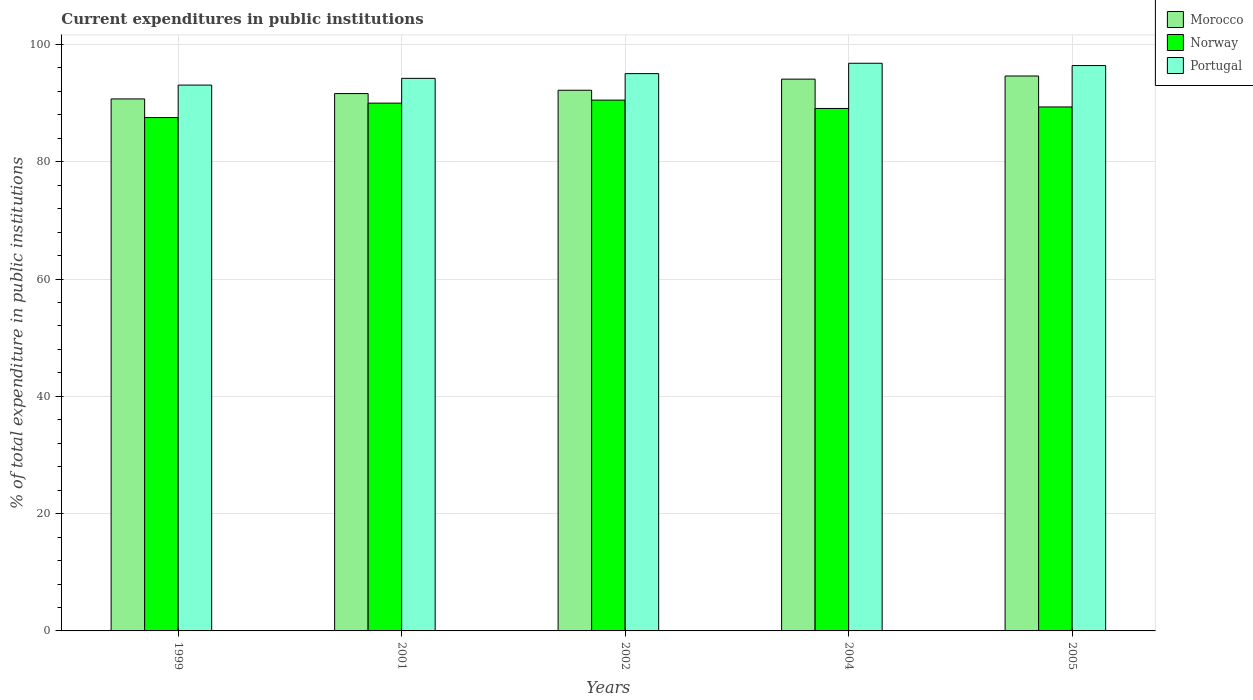How many groups of bars are there?
Offer a very short reply. 5. Are the number of bars per tick equal to the number of legend labels?
Make the answer very short. Yes. How many bars are there on the 4th tick from the left?
Your response must be concise. 3. How many bars are there on the 1st tick from the right?
Keep it short and to the point. 3. What is the current expenditures in public institutions in Norway in 1999?
Ensure brevity in your answer.  87.53. Across all years, what is the maximum current expenditures in public institutions in Norway?
Keep it short and to the point. 90.51. Across all years, what is the minimum current expenditures in public institutions in Morocco?
Offer a terse response. 90.71. What is the total current expenditures in public institutions in Norway in the graph?
Your response must be concise. 446.46. What is the difference between the current expenditures in public institutions in Portugal in 2002 and that in 2004?
Provide a short and direct response. -1.77. What is the difference between the current expenditures in public institutions in Portugal in 1999 and the current expenditures in public institutions in Morocco in 2004?
Give a very brief answer. -1.01. What is the average current expenditures in public institutions in Morocco per year?
Provide a short and direct response. 92.65. In the year 2002, what is the difference between the current expenditures in public institutions in Morocco and current expenditures in public institutions in Portugal?
Make the answer very short. -2.84. In how many years, is the current expenditures in public institutions in Portugal greater than 64 %?
Give a very brief answer. 5. What is the ratio of the current expenditures in public institutions in Norway in 2002 to that in 2004?
Offer a very short reply. 1.02. What is the difference between the highest and the second highest current expenditures in public institutions in Norway?
Your response must be concise. 0.52. What is the difference between the highest and the lowest current expenditures in public institutions in Norway?
Your answer should be compact. 2.98. Is the sum of the current expenditures in public institutions in Norway in 1999 and 2005 greater than the maximum current expenditures in public institutions in Morocco across all years?
Offer a terse response. Yes. What does the 2nd bar from the left in 2001 represents?
Your answer should be very brief. Norway. How many bars are there?
Offer a terse response. 15. Are all the bars in the graph horizontal?
Make the answer very short. No. How many years are there in the graph?
Your response must be concise. 5. Are the values on the major ticks of Y-axis written in scientific E-notation?
Your answer should be very brief. No. Where does the legend appear in the graph?
Ensure brevity in your answer.  Top right. How many legend labels are there?
Your response must be concise. 3. What is the title of the graph?
Your answer should be compact. Current expenditures in public institutions. What is the label or title of the X-axis?
Provide a short and direct response. Years. What is the label or title of the Y-axis?
Offer a terse response. % of total expenditure in public institutions. What is the % of total expenditure in public institutions of Morocco in 1999?
Offer a terse response. 90.71. What is the % of total expenditure in public institutions in Norway in 1999?
Give a very brief answer. 87.53. What is the % of total expenditure in public institutions of Portugal in 1999?
Provide a short and direct response. 93.07. What is the % of total expenditure in public institutions in Morocco in 2001?
Offer a terse response. 91.63. What is the % of total expenditure in public institutions in Norway in 2001?
Your answer should be compact. 89.99. What is the % of total expenditure in public institutions in Portugal in 2001?
Make the answer very short. 94.22. What is the % of total expenditure in public institutions of Morocco in 2002?
Keep it short and to the point. 92.19. What is the % of total expenditure in public institutions in Norway in 2002?
Your answer should be compact. 90.51. What is the % of total expenditure in public institutions of Portugal in 2002?
Your answer should be very brief. 95.03. What is the % of total expenditure in public institutions in Morocco in 2004?
Provide a short and direct response. 94.09. What is the % of total expenditure in public institutions in Norway in 2004?
Offer a very short reply. 89.09. What is the % of total expenditure in public institutions in Portugal in 2004?
Make the answer very short. 96.79. What is the % of total expenditure in public institutions in Morocco in 2005?
Provide a succinct answer. 94.62. What is the % of total expenditure in public institutions in Norway in 2005?
Provide a succinct answer. 89.34. What is the % of total expenditure in public institutions of Portugal in 2005?
Ensure brevity in your answer.  96.4. Across all years, what is the maximum % of total expenditure in public institutions in Morocco?
Your answer should be very brief. 94.62. Across all years, what is the maximum % of total expenditure in public institutions of Norway?
Make the answer very short. 90.51. Across all years, what is the maximum % of total expenditure in public institutions in Portugal?
Make the answer very short. 96.79. Across all years, what is the minimum % of total expenditure in public institutions of Morocco?
Your answer should be very brief. 90.71. Across all years, what is the minimum % of total expenditure in public institutions of Norway?
Offer a very short reply. 87.53. Across all years, what is the minimum % of total expenditure in public institutions of Portugal?
Make the answer very short. 93.07. What is the total % of total expenditure in public institutions of Morocco in the graph?
Keep it short and to the point. 463.23. What is the total % of total expenditure in public institutions in Norway in the graph?
Your answer should be very brief. 446.46. What is the total % of total expenditure in public institutions in Portugal in the graph?
Offer a very short reply. 475.51. What is the difference between the % of total expenditure in public institutions in Morocco in 1999 and that in 2001?
Your response must be concise. -0.92. What is the difference between the % of total expenditure in public institutions of Norway in 1999 and that in 2001?
Make the answer very short. -2.46. What is the difference between the % of total expenditure in public institutions in Portugal in 1999 and that in 2001?
Provide a short and direct response. -1.15. What is the difference between the % of total expenditure in public institutions of Morocco in 1999 and that in 2002?
Keep it short and to the point. -1.48. What is the difference between the % of total expenditure in public institutions in Norway in 1999 and that in 2002?
Provide a succinct answer. -2.98. What is the difference between the % of total expenditure in public institutions in Portugal in 1999 and that in 2002?
Offer a terse response. -1.96. What is the difference between the % of total expenditure in public institutions in Morocco in 1999 and that in 2004?
Ensure brevity in your answer.  -3.38. What is the difference between the % of total expenditure in public institutions in Norway in 1999 and that in 2004?
Offer a very short reply. -1.55. What is the difference between the % of total expenditure in public institutions in Portugal in 1999 and that in 2004?
Give a very brief answer. -3.72. What is the difference between the % of total expenditure in public institutions in Morocco in 1999 and that in 2005?
Provide a short and direct response. -3.91. What is the difference between the % of total expenditure in public institutions in Norway in 1999 and that in 2005?
Your response must be concise. -1.81. What is the difference between the % of total expenditure in public institutions of Portugal in 1999 and that in 2005?
Provide a short and direct response. -3.33. What is the difference between the % of total expenditure in public institutions of Morocco in 2001 and that in 2002?
Provide a short and direct response. -0.57. What is the difference between the % of total expenditure in public institutions of Norway in 2001 and that in 2002?
Your response must be concise. -0.52. What is the difference between the % of total expenditure in public institutions in Portugal in 2001 and that in 2002?
Ensure brevity in your answer.  -0.8. What is the difference between the % of total expenditure in public institutions of Morocco in 2001 and that in 2004?
Your answer should be very brief. -2.46. What is the difference between the % of total expenditure in public institutions in Norway in 2001 and that in 2004?
Your answer should be compact. 0.91. What is the difference between the % of total expenditure in public institutions in Portugal in 2001 and that in 2004?
Keep it short and to the point. -2.57. What is the difference between the % of total expenditure in public institutions of Morocco in 2001 and that in 2005?
Ensure brevity in your answer.  -2.99. What is the difference between the % of total expenditure in public institutions in Norway in 2001 and that in 2005?
Make the answer very short. 0.65. What is the difference between the % of total expenditure in public institutions of Portugal in 2001 and that in 2005?
Give a very brief answer. -2.18. What is the difference between the % of total expenditure in public institutions of Morocco in 2002 and that in 2004?
Offer a very short reply. -1.89. What is the difference between the % of total expenditure in public institutions of Norway in 2002 and that in 2004?
Your answer should be compact. 1.42. What is the difference between the % of total expenditure in public institutions of Portugal in 2002 and that in 2004?
Your answer should be very brief. -1.77. What is the difference between the % of total expenditure in public institutions of Morocco in 2002 and that in 2005?
Make the answer very short. -2.43. What is the difference between the % of total expenditure in public institutions of Norway in 2002 and that in 2005?
Your answer should be very brief. 1.17. What is the difference between the % of total expenditure in public institutions of Portugal in 2002 and that in 2005?
Offer a very short reply. -1.37. What is the difference between the % of total expenditure in public institutions in Morocco in 2004 and that in 2005?
Make the answer very short. -0.53. What is the difference between the % of total expenditure in public institutions of Norway in 2004 and that in 2005?
Your answer should be compact. -0.26. What is the difference between the % of total expenditure in public institutions of Portugal in 2004 and that in 2005?
Provide a succinct answer. 0.39. What is the difference between the % of total expenditure in public institutions in Morocco in 1999 and the % of total expenditure in public institutions in Norway in 2001?
Ensure brevity in your answer.  0.72. What is the difference between the % of total expenditure in public institutions of Morocco in 1999 and the % of total expenditure in public institutions of Portugal in 2001?
Give a very brief answer. -3.51. What is the difference between the % of total expenditure in public institutions in Norway in 1999 and the % of total expenditure in public institutions in Portugal in 2001?
Your answer should be compact. -6.69. What is the difference between the % of total expenditure in public institutions in Morocco in 1999 and the % of total expenditure in public institutions in Norway in 2002?
Provide a succinct answer. 0.2. What is the difference between the % of total expenditure in public institutions in Morocco in 1999 and the % of total expenditure in public institutions in Portugal in 2002?
Give a very brief answer. -4.32. What is the difference between the % of total expenditure in public institutions of Norway in 1999 and the % of total expenditure in public institutions of Portugal in 2002?
Offer a very short reply. -7.49. What is the difference between the % of total expenditure in public institutions in Morocco in 1999 and the % of total expenditure in public institutions in Norway in 2004?
Offer a terse response. 1.62. What is the difference between the % of total expenditure in public institutions in Morocco in 1999 and the % of total expenditure in public institutions in Portugal in 2004?
Your response must be concise. -6.08. What is the difference between the % of total expenditure in public institutions in Norway in 1999 and the % of total expenditure in public institutions in Portugal in 2004?
Offer a very short reply. -9.26. What is the difference between the % of total expenditure in public institutions in Morocco in 1999 and the % of total expenditure in public institutions in Norway in 2005?
Provide a succinct answer. 1.37. What is the difference between the % of total expenditure in public institutions in Morocco in 1999 and the % of total expenditure in public institutions in Portugal in 2005?
Provide a short and direct response. -5.69. What is the difference between the % of total expenditure in public institutions in Norway in 1999 and the % of total expenditure in public institutions in Portugal in 2005?
Ensure brevity in your answer.  -8.87. What is the difference between the % of total expenditure in public institutions of Morocco in 2001 and the % of total expenditure in public institutions of Norway in 2002?
Your answer should be very brief. 1.12. What is the difference between the % of total expenditure in public institutions in Morocco in 2001 and the % of total expenditure in public institutions in Portugal in 2002?
Offer a very short reply. -3.4. What is the difference between the % of total expenditure in public institutions in Norway in 2001 and the % of total expenditure in public institutions in Portugal in 2002?
Ensure brevity in your answer.  -5.03. What is the difference between the % of total expenditure in public institutions of Morocco in 2001 and the % of total expenditure in public institutions of Norway in 2004?
Offer a terse response. 2.54. What is the difference between the % of total expenditure in public institutions of Morocco in 2001 and the % of total expenditure in public institutions of Portugal in 2004?
Your answer should be very brief. -5.17. What is the difference between the % of total expenditure in public institutions in Norway in 2001 and the % of total expenditure in public institutions in Portugal in 2004?
Your response must be concise. -6.8. What is the difference between the % of total expenditure in public institutions of Morocco in 2001 and the % of total expenditure in public institutions of Norway in 2005?
Your response must be concise. 2.28. What is the difference between the % of total expenditure in public institutions in Morocco in 2001 and the % of total expenditure in public institutions in Portugal in 2005?
Make the answer very short. -4.77. What is the difference between the % of total expenditure in public institutions in Norway in 2001 and the % of total expenditure in public institutions in Portugal in 2005?
Your response must be concise. -6.41. What is the difference between the % of total expenditure in public institutions in Morocco in 2002 and the % of total expenditure in public institutions in Norway in 2004?
Provide a succinct answer. 3.11. What is the difference between the % of total expenditure in public institutions of Morocco in 2002 and the % of total expenditure in public institutions of Portugal in 2004?
Ensure brevity in your answer.  -4.6. What is the difference between the % of total expenditure in public institutions of Norway in 2002 and the % of total expenditure in public institutions of Portugal in 2004?
Keep it short and to the point. -6.28. What is the difference between the % of total expenditure in public institutions in Morocco in 2002 and the % of total expenditure in public institutions in Norway in 2005?
Provide a short and direct response. 2.85. What is the difference between the % of total expenditure in public institutions of Morocco in 2002 and the % of total expenditure in public institutions of Portugal in 2005?
Provide a succinct answer. -4.21. What is the difference between the % of total expenditure in public institutions in Norway in 2002 and the % of total expenditure in public institutions in Portugal in 2005?
Offer a terse response. -5.89. What is the difference between the % of total expenditure in public institutions of Morocco in 2004 and the % of total expenditure in public institutions of Norway in 2005?
Give a very brief answer. 4.74. What is the difference between the % of total expenditure in public institutions in Morocco in 2004 and the % of total expenditure in public institutions in Portugal in 2005?
Make the answer very short. -2.32. What is the difference between the % of total expenditure in public institutions in Norway in 2004 and the % of total expenditure in public institutions in Portugal in 2005?
Offer a terse response. -7.31. What is the average % of total expenditure in public institutions of Morocco per year?
Ensure brevity in your answer.  92.65. What is the average % of total expenditure in public institutions of Norway per year?
Ensure brevity in your answer.  89.29. What is the average % of total expenditure in public institutions in Portugal per year?
Ensure brevity in your answer.  95.1. In the year 1999, what is the difference between the % of total expenditure in public institutions of Morocco and % of total expenditure in public institutions of Norway?
Your response must be concise. 3.18. In the year 1999, what is the difference between the % of total expenditure in public institutions of Morocco and % of total expenditure in public institutions of Portugal?
Your response must be concise. -2.36. In the year 1999, what is the difference between the % of total expenditure in public institutions in Norway and % of total expenditure in public institutions in Portugal?
Offer a terse response. -5.54. In the year 2001, what is the difference between the % of total expenditure in public institutions in Morocco and % of total expenditure in public institutions in Norway?
Give a very brief answer. 1.63. In the year 2001, what is the difference between the % of total expenditure in public institutions in Morocco and % of total expenditure in public institutions in Portugal?
Provide a short and direct response. -2.6. In the year 2001, what is the difference between the % of total expenditure in public institutions of Norway and % of total expenditure in public institutions of Portugal?
Your response must be concise. -4.23. In the year 2002, what is the difference between the % of total expenditure in public institutions of Morocco and % of total expenditure in public institutions of Norway?
Keep it short and to the point. 1.68. In the year 2002, what is the difference between the % of total expenditure in public institutions of Morocco and % of total expenditure in public institutions of Portugal?
Make the answer very short. -2.84. In the year 2002, what is the difference between the % of total expenditure in public institutions of Norway and % of total expenditure in public institutions of Portugal?
Your response must be concise. -4.52. In the year 2004, what is the difference between the % of total expenditure in public institutions in Morocco and % of total expenditure in public institutions in Norway?
Make the answer very short. 5. In the year 2004, what is the difference between the % of total expenditure in public institutions of Morocco and % of total expenditure in public institutions of Portugal?
Offer a terse response. -2.71. In the year 2004, what is the difference between the % of total expenditure in public institutions in Norway and % of total expenditure in public institutions in Portugal?
Provide a succinct answer. -7.71. In the year 2005, what is the difference between the % of total expenditure in public institutions of Morocco and % of total expenditure in public institutions of Norway?
Keep it short and to the point. 5.28. In the year 2005, what is the difference between the % of total expenditure in public institutions of Morocco and % of total expenditure in public institutions of Portugal?
Make the answer very short. -1.78. In the year 2005, what is the difference between the % of total expenditure in public institutions in Norway and % of total expenditure in public institutions in Portugal?
Your answer should be very brief. -7.06. What is the ratio of the % of total expenditure in public institutions of Norway in 1999 to that in 2001?
Your answer should be very brief. 0.97. What is the ratio of the % of total expenditure in public institutions in Portugal in 1999 to that in 2001?
Your answer should be compact. 0.99. What is the ratio of the % of total expenditure in public institutions of Morocco in 1999 to that in 2002?
Ensure brevity in your answer.  0.98. What is the ratio of the % of total expenditure in public institutions in Norway in 1999 to that in 2002?
Offer a very short reply. 0.97. What is the ratio of the % of total expenditure in public institutions in Portugal in 1999 to that in 2002?
Offer a terse response. 0.98. What is the ratio of the % of total expenditure in public institutions of Morocco in 1999 to that in 2004?
Keep it short and to the point. 0.96. What is the ratio of the % of total expenditure in public institutions in Norway in 1999 to that in 2004?
Your answer should be compact. 0.98. What is the ratio of the % of total expenditure in public institutions of Portugal in 1999 to that in 2004?
Your answer should be very brief. 0.96. What is the ratio of the % of total expenditure in public institutions of Morocco in 1999 to that in 2005?
Your answer should be very brief. 0.96. What is the ratio of the % of total expenditure in public institutions in Norway in 1999 to that in 2005?
Give a very brief answer. 0.98. What is the ratio of the % of total expenditure in public institutions in Portugal in 1999 to that in 2005?
Offer a very short reply. 0.97. What is the ratio of the % of total expenditure in public institutions of Morocco in 2001 to that in 2002?
Your answer should be compact. 0.99. What is the ratio of the % of total expenditure in public institutions of Norway in 2001 to that in 2002?
Ensure brevity in your answer.  0.99. What is the ratio of the % of total expenditure in public institutions of Morocco in 2001 to that in 2004?
Ensure brevity in your answer.  0.97. What is the ratio of the % of total expenditure in public institutions in Norway in 2001 to that in 2004?
Provide a short and direct response. 1.01. What is the ratio of the % of total expenditure in public institutions in Portugal in 2001 to that in 2004?
Offer a terse response. 0.97. What is the ratio of the % of total expenditure in public institutions of Morocco in 2001 to that in 2005?
Keep it short and to the point. 0.97. What is the ratio of the % of total expenditure in public institutions in Norway in 2001 to that in 2005?
Offer a terse response. 1.01. What is the ratio of the % of total expenditure in public institutions in Portugal in 2001 to that in 2005?
Your response must be concise. 0.98. What is the ratio of the % of total expenditure in public institutions in Morocco in 2002 to that in 2004?
Provide a succinct answer. 0.98. What is the ratio of the % of total expenditure in public institutions of Norway in 2002 to that in 2004?
Offer a very short reply. 1.02. What is the ratio of the % of total expenditure in public institutions of Portugal in 2002 to that in 2004?
Your response must be concise. 0.98. What is the ratio of the % of total expenditure in public institutions of Morocco in 2002 to that in 2005?
Offer a very short reply. 0.97. What is the ratio of the % of total expenditure in public institutions of Portugal in 2002 to that in 2005?
Your answer should be compact. 0.99. What is the ratio of the % of total expenditure in public institutions in Norway in 2004 to that in 2005?
Provide a succinct answer. 1. What is the ratio of the % of total expenditure in public institutions of Portugal in 2004 to that in 2005?
Provide a succinct answer. 1. What is the difference between the highest and the second highest % of total expenditure in public institutions of Morocco?
Offer a terse response. 0.53. What is the difference between the highest and the second highest % of total expenditure in public institutions of Norway?
Your response must be concise. 0.52. What is the difference between the highest and the second highest % of total expenditure in public institutions of Portugal?
Provide a succinct answer. 0.39. What is the difference between the highest and the lowest % of total expenditure in public institutions of Morocco?
Your answer should be very brief. 3.91. What is the difference between the highest and the lowest % of total expenditure in public institutions in Norway?
Your answer should be very brief. 2.98. What is the difference between the highest and the lowest % of total expenditure in public institutions of Portugal?
Keep it short and to the point. 3.72. 